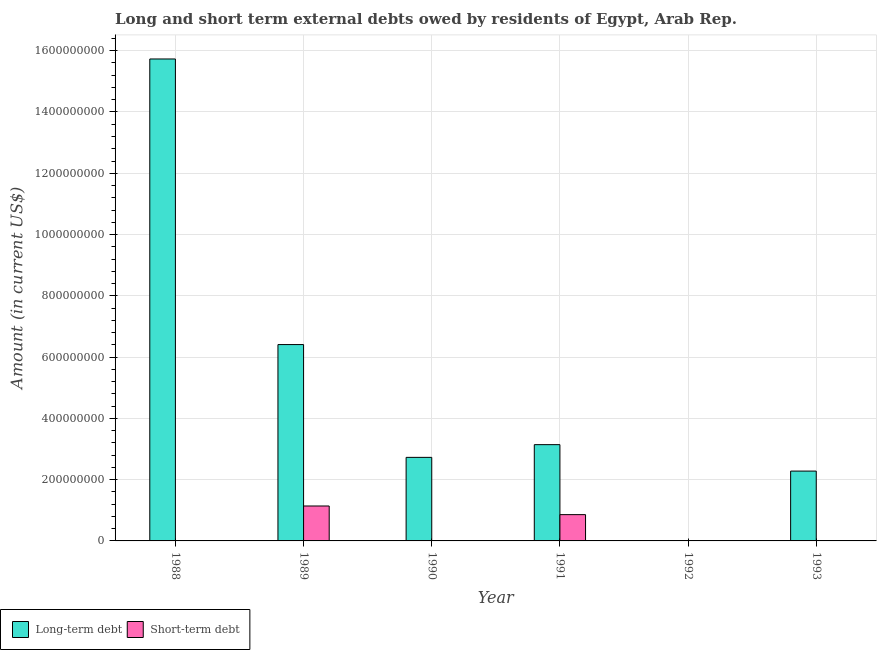How many different coloured bars are there?
Your answer should be very brief. 2. Are the number of bars on each tick of the X-axis equal?
Offer a terse response. No. How many bars are there on the 6th tick from the right?
Offer a terse response. 1. What is the label of the 1st group of bars from the left?
Provide a short and direct response. 1988. Across all years, what is the maximum short-term debts owed by residents?
Ensure brevity in your answer.  1.14e+08. What is the total short-term debts owed by residents in the graph?
Offer a terse response. 2.00e+08. What is the difference between the long-term debts owed by residents in 1989 and that in 1993?
Provide a succinct answer. 4.13e+08. What is the difference between the long-term debts owed by residents in 1990 and the short-term debts owed by residents in 1989?
Provide a succinct answer. -3.68e+08. What is the average long-term debts owed by residents per year?
Ensure brevity in your answer.  5.05e+08. What is the ratio of the long-term debts owed by residents in 1990 to that in 1991?
Your answer should be very brief. 0.87. What is the difference between the highest and the second highest long-term debts owed by residents?
Provide a short and direct response. 9.32e+08. What is the difference between the highest and the lowest short-term debts owed by residents?
Keep it short and to the point. 1.14e+08. In how many years, is the short-term debts owed by residents greater than the average short-term debts owed by residents taken over all years?
Offer a terse response. 2. How many bars are there?
Your answer should be very brief. 7. How many years are there in the graph?
Your response must be concise. 6. Where does the legend appear in the graph?
Keep it short and to the point. Bottom left. How many legend labels are there?
Make the answer very short. 2. What is the title of the graph?
Offer a terse response. Long and short term external debts owed by residents of Egypt, Arab Rep. Does "Enforce a contract" appear as one of the legend labels in the graph?
Provide a succinct answer. No. What is the Amount (in current US$) of Long-term debt in 1988?
Keep it short and to the point. 1.57e+09. What is the Amount (in current US$) in Long-term debt in 1989?
Offer a terse response. 6.41e+08. What is the Amount (in current US$) in Short-term debt in 1989?
Your answer should be very brief. 1.14e+08. What is the Amount (in current US$) of Long-term debt in 1990?
Make the answer very short. 2.73e+08. What is the Amount (in current US$) of Long-term debt in 1991?
Your answer should be compact. 3.14e+08. What is the Amount (in current US$) of Short-term debt in 1991?
Provide a short and direct response. 8.58e+07. What is the Amount (in current US$) of Long-term debt in 1992?
Your response must be concise. 0. What is the Amount (in current US$) of Short-term debt in 1992?
Ensure brevity in your answer.  0. What is the Amount (in current US$) of Long-term debt in 1993?
Offer a very short reply. 2.28e+08. What is the Amount (in current US$) of Short-term debt in 1993?
Provide a short and direct response. 0. Across all years, what is the maximum Amount (in current US$) of Long-term debt?
Provide a succinct answer. 1.57e+09. Across all years, what is the maximum Amount (in current US$) of Short-term debt?
Your answer should be compact. 1.14e+08. Across all years, what is the minimum Amount (in current US$) in Long-term debt?
Give a very brief answer. 0. What is the total Amount (in current US$) of Long-term debt in the graph?
Your answer should be very brief. 3.03e+09. What is the total Amount (in current US$) of Short-term debt in the graph?
Your answer should be very brief. 2.00e+08. What is the difference between the Amount (in current US$) in Long-term debt in 1988 and that in 1989?
Provide a short and direct response. 9.32e+08. What is the difference between the Amount (in current US$) in Long-term debt in 1988 and that in 1990?
Give a very brief answer. 1.30e+09. What is the difference between the Amount (in current US$) of Long-term debt in 1988 and that in 1991?
Keep it short and to the point. 1.26e+09. What is the difference between the Amount (in current US$) of Long-term debt in 1988 and that in 1993?
Make the answer very short. 1.35e+09. What is the difference between the Amount (in current US$) of Long-term debt in 1989 and that in 1990?
Give a very brief answer. 3.68e+08. What is the difference between the Amount (in current US$) in Long-term debt in 1989 and that in 1991?
Provide a succinct answer. 3.27e+08. What is the difference between the Amount (in current US$) in Short-term debt in 1989 and that in 1991?
Your answer should be very brief. 2.82e+07. What is the difference between the Amount (in current US$) in Long-term debt in 1989 and that in 1993?
Ensure brevity in your answer.  4.13e+08. What is the difference between the Amount (in current US$) in Long-term debt in 1990 and that in 1991?
Keep it short and to the point. -4.15e+07. What is the difference between the Amount (in current US$) in Long-term debt in 1990 and that in 1993?
Offer a terse response. 4.48e+07. What is the difference between the Amount (in current US$) of Long-term debt in 1991 and that in 1993?
Your response must be concise. 8.63e+07. What is the difference between the Amount (in current US$) of Long-term debt in 1988 and the Amount (in current US$) of Short-term debt in 1989?
Offer a very short reply. 1.46e+09. What is the difference between the Amount (in current US$) of Long-term debt in 1988 and the Amount (in current US$) of Short-term debt in 1991?
Your answer should be compact. 1.49e+09. What is the difference between the Amount (in current US$) of Long-term debt in 1989 and the Amount (in current US$) of Short-term debt in 1991?
Offer a terse response. 5.55e+08. What is the difference between the Amount (in current US$) of Long-term debt in 1990 and the Amount (in current US$) of Short-term debt in 1991?
Offer a very short reply. 1.87e+08. What is the average Amount (in current US$) in Long-term debt per year?
Provide a short and direct response. 5.05e+08. What is the average Amount (in current US$) of Short-term debt per year?
Provide a short and direct response. 3.33e+07. In the year 1989, what is the difference between the Amount (in current US$) in Long-term debt and Amount (in current US$) in Short-term debt?
Your answer should be very brief. 5.27e+08. In the year 1991, what is the difference between the Amount (in current US$) of Long-term debt and Amount (in current US$) of Short-term debt?
Keep it short and to the point. 2.28e+08. What is the ratio of the Amount (in current US$) in Long-term debt in 1988 to that in 1989?
Your answer should be compact. 2.45. What is the ratio of the Amount (in current US$) of Long-term debt in 1988 to that in 1990?
Ensure brevity in your answer.  5.77. What is the ratio of the Amount (in current US$) in Long-term debt in 1988 to that in 1991?
Provide a short and direct response. 5.01. What is the ratio of the Amount (in current US$) of Long-term debt in 1988 to that in 1993?
Offer a terse response. 6.9. What is the ratio of the Amount (in current US$) in Long-term debt in 1989 to that in 1990?
Provide a short and direct response. 2.35. What is the ratio of the Amount (in current US$) in Long-term debt in 1989 to that in 1991?
Offer a terse response. 2.04. What is the ratio of the Amount (in current US$) in Short-term debt in 1989 to that in 1991?
Your answer should be very brief. 1.33. What is the ratio of the Amount (in current US$) in Long-term debt in 1989 to that in 1993?
Provide a short and direct response. 2.81. What is the ratio of the Amount (in current US$) in Long-term debt in 1990 to that in 1991?
Your answer should be compact. 0.87. What is the ratio of the Amount (in current US$) in Long-term debt in 1990 to that in 1993?
Your response must be concise. 1.2. What is the ratio of the Amount (in current US$) in Long-term debt in 1991 to that in 1993?
Your response must be concise. 1.38. What is the difference between the highest and the second highest Amount (in current US$) in Long-term debt?
Your answer should be very brief. 9.32e+08. What is the difference between the highest and the lowest Amount (in current US$) in Long-term debt?
Keep it short and to the point. 1.57e+09. What is the difference between the highest and the lowest Amount (in current US$) of Short-term debt?
Ensure brevity in your answer.  1.14e+08. 